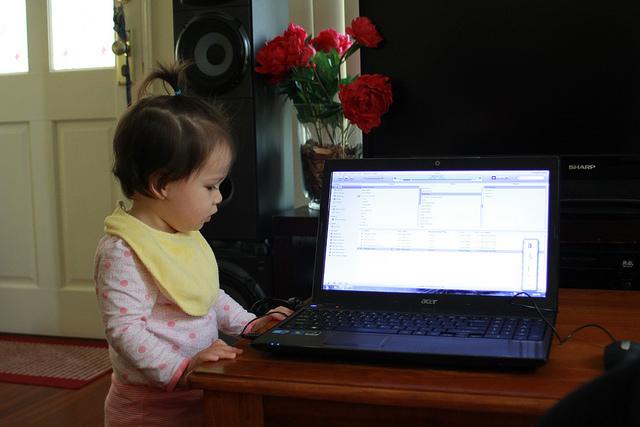What kind of flowers are in the vase?
Quick response, please. Roses. Does the child have a father?
Quick response, please. Yes. What color is the child's hair?
Be succinct. Brown. What is the girl playing?
Answer briefly. Computer. What color of bib is this kid wearing?
Concise answer only. Yellow. 